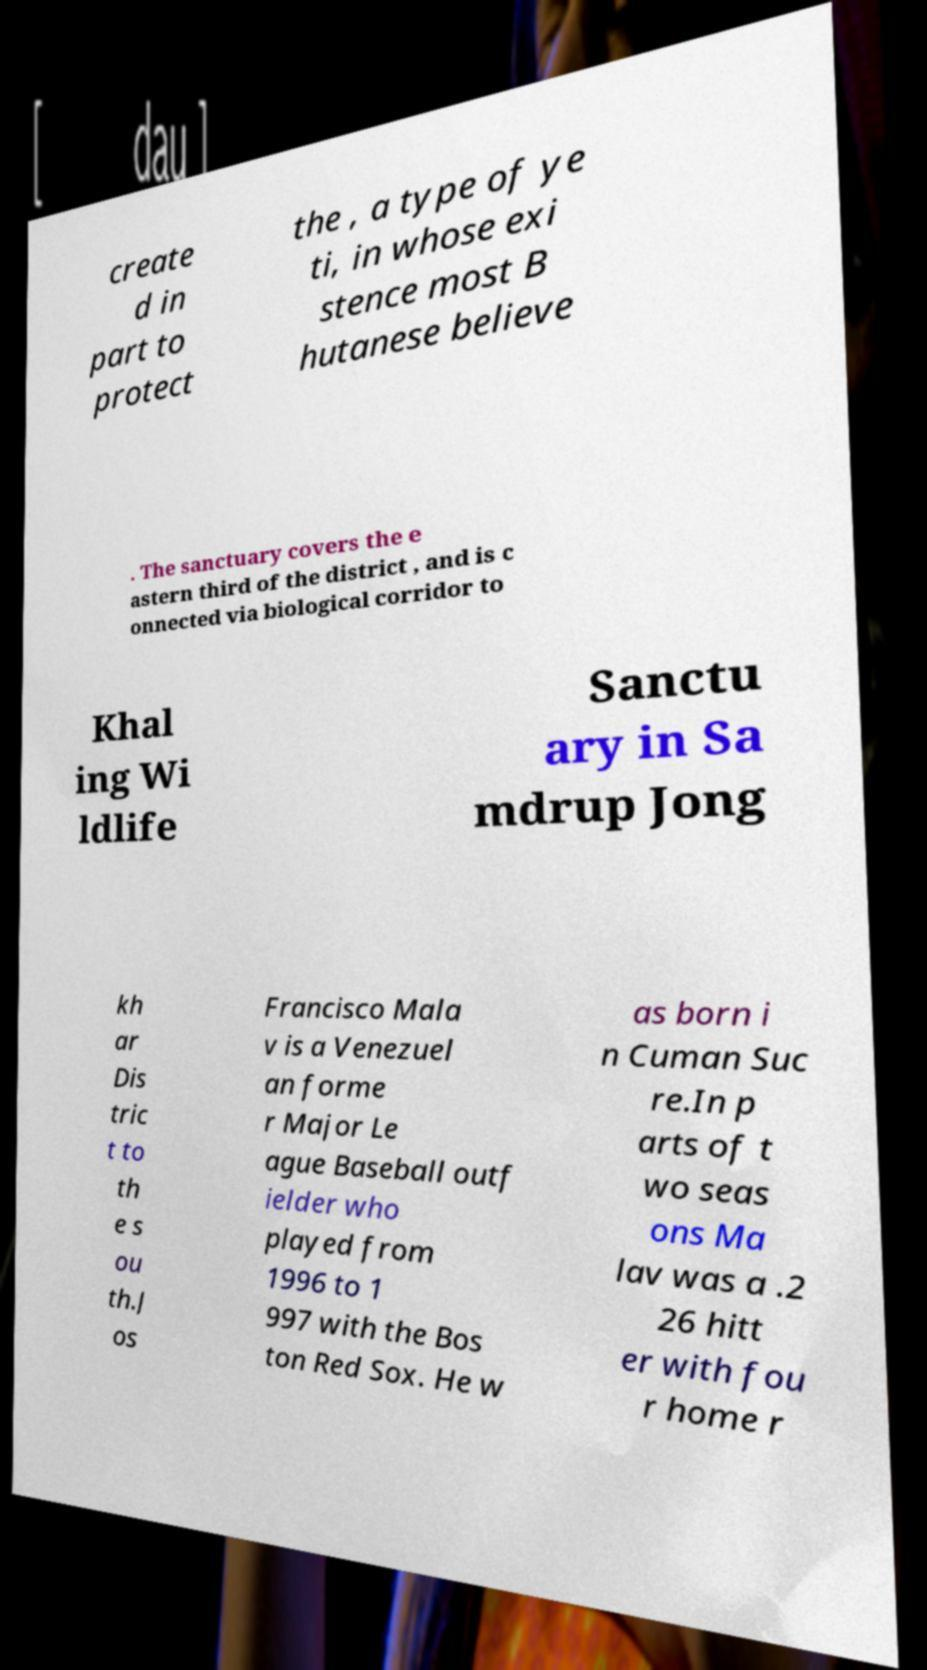Can you accurately transcribe the text from the provided image for me? create d in part to protect the , a type of ye ti, in whose exi stence most B hutanese believe . The sanctuary covers the e astern third of the district , and is c onnected via biological corridor to Khal ing Wi ldlife Sanctu ary in Sa mdrup Jong kh ar Dis tric t to th e s ou th.J os Francisco Mala v is a Venezuel an forme r Major Le ague Baseball outf ielder who played from 1996 to 1 997 with the Bos ton Red Sox. He w as born i n Cuman Suc re.In p arts of t wo seas ons Ma lav was a .2 26 hitt er with fou r home r 